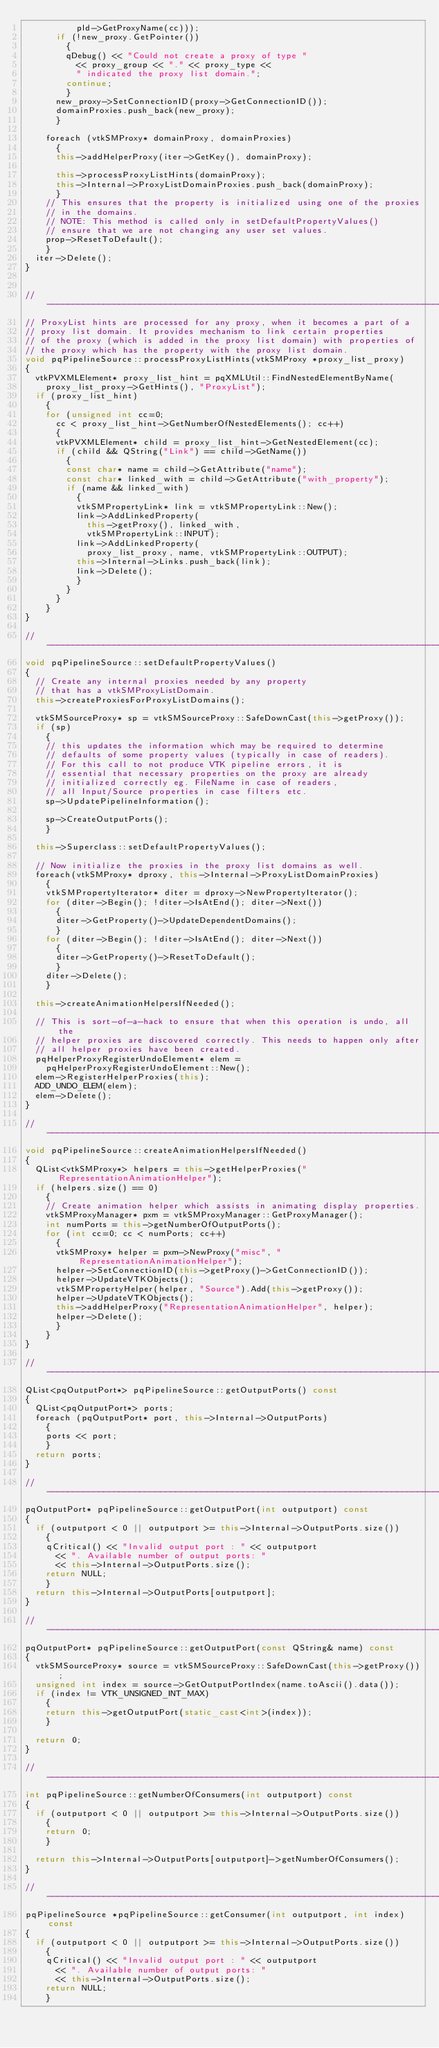<code> <loc_0><loc_0><loc_500><loc_500><_C++_>          pld->GetProxyName(cc)));
      if (!new_proxy.GetPointer())
        {
        qDebug() << "Could not create a proxy of type " 
          << proxy_group << "." << proxy_type <<
          " indicated the proxy list domain.";
        continue;
        }
      new_proxy->SetConnectionID(proxy->GetConnectionID());
      domainProxies.push_back(new_proxy);
      }

    foreach (vtkSMProxy* domainProxy, domainProxies)
      {
      this->addHelperProxy(iter->GetKey(), domainProxy);

      this->processProxyListHints(domainProxy);
      this->Internal->ProxyListDomainProxies.push_back(domainProxy);
      }
    // This ensures that the property is initialized using one of the proxies
    // in the domains.
    // NOTE: This method is called only in setDefaultPropertyValues()
    // ensure that we are not changing any user set values.
    prop->ResetToDefault();
    }
  iter->Delete();
}


//-----------------------------------------------------------------------------
// ProxyList hints are processed for any proxy, when it becomes a part of a 
// proxy list domain. It provides mechanism to link certain properties
// of the proxy (which is added in the proxy list domain) with properties of 
// the proxy which has the property with the proxy list domain.
void pqPipelineSource::processProxyListHints(vtkSMProxy *proxy_list_proxy)
{
  vtkPVXMLElement* proxy_list_hint = pqXMLUtil::FindNestedElementByName(
    proxy_list_proxy->GetHints(), "ProxyList");
  if (proxy_list_hint)
    {
    for (unsigned int cc=0; 
      cc < proxy_list_hint->GetNumberOfNestedElements(); cc++)
      {
      vtkPVXMLElement* child = proxy_list_hint->GetNestedElement(cc);
      if (child && QString("Link") == child->GetName())
        {
        const char* name = child->GetAttribute("name");
        const char* linked_with = child->GetAttribute("with_property");
        if (name && linked_with)
          {
          vtkSMPropertyLink* link = vtkSMPropertyLink::New();
          link->AddLinkedProperty(
            this->getProxy(), linked_with,
            vtkSMPropertyLink::INPUT);
          link->AddLinkedProperty(
            proxy_list_proxy, name, vtkSMPropertyLink::OUTPUT);
          this->Internal->Links.push_back(link);
          link->Delete();
          }
        }
      }
    }
}

//-----------------------------------------------------------------------------
void pqPipelineSource::setDefaultPropertyValues()
{
  // Create any internal proxies needed by any property
  // that has a vtkSMProxyListDomain.
  this->createProxiesForProxyListDomains();

  vtkSMSourceProxy* sp = vtkSMSourceProxy::SafeDownCast(this->getProxy());
  if (sp)
    {
    // this updates the information which may be required to determine
    // defaults of some property values (typically in case of readers).
    // For this call to not produce VTK pipeline errors, it is 
    // essential that necessary properties on the proxy are already
    // initialized correctly eg. FileName in case of readers,
    // all Input/Source properties in case filters etc.
    sp->UpdatePipelineInformation();

    sp->CreateOutputPorts();
    }

  this->Superclass::setDefaultPropertyValues();

  // Now initialize the proxies in the proxy list domains as well. 
  foreach(vtkSMProxy* dproxy, this->Internal->ProxyListDomainProxies)
    {
    vtkSMPropertyIterator* diter = dproxy->NewPropertyIterator();
    for (diter->Begin(); !diter->IsAtEnd(); diter->Next())
      {
      diter->GetProperty()->UpdateDependentDomains();
      }
    for (diter->Begin(); !diter->IsAtEnd(); diter->Next())
      {
      diter->GetProperty()->ResetToDefault();
      }
    diter->Delete();
    }

  this->createAnimationHelpersIfNeeded();

  // This is sort-of-a-hack to ensure that when this operation is undo, all the
  // helper proxies are discovered correctly. This needs to happen only after
  // all helper proxies have been created.
  pqHelperProxyRegisterUndoElement* elem = 
    pqHelperProxyRegisterUndoElement::New();
  elem->RegisterHelperProxies(this);
  ADD_UNDO_ELEM(elem);
  elem->Delete();
}

//-----------------------------------------------------------------------------
void pqPipelineSource::createAnimationHelpersIfNeeded()
{
  QList<vtkSMProxy*> helpers = this->getHelperProxies("RepresentationAnimationHelper");
  if (helpers.size() == 0)
    {
    // Create animation helper which assists in animating display properties.
    vtkSMProxyManager* pxm = vtkSMProxyManager::GetProxyManager();
    int numPorts = this->getNumberOfOutputPorts();
    for (int cc=0; cc < numPorts; cc++)
      {
      vtkSMProxy* helper = pxm->NewProxy("misc", "RepresentationAnimationHelper");
      helper->SetConnectionID(this->getProxy()->GetConnectionID());
      helper->UpdateVTKObjects();
      vtkSMPropertyHelper(helper, "Source").Add(this->getProxy());
      helper->UpdateVTKObjects();
      this->addHelperProxy("RepresentationAnimationHelper", helper);
      helper->Delete();
      }
    }
}

//-----------------------------------------------------------------------------
QList<pqOutputPort*> pqPipelineSource::getOutputPorts() const
{
  QList<pqOutputPort*> ports;
  foreach (pqOutputPort* port, this->Internal->OutputPorts)
    {
    ports << port;
    }
  return ports;
}

//-----------------------------------------------------------------------------
pqOutputPort* pqPipelineSource::getOutputPort(int outputport) const
{
  if (outputport < 0 || outputport >= this->Internal->OutputPorts.size())
    {
    qCritical() << "Invalid output port : " << outputport
      << ". Available number of output ports: " 
      << this->Internal->OutputPorts.size();
    return NULL;
    }
  return this->Internal->OutputPorts[outputport];
}

//-----------------------------------------------------------------------------
pqOutputPort* pqPipelineSource::getOutputPort(const QString& name) const
{
  vtkSMSourceProxy* source = vtkSMSourceProxy::SafeDownCast(this->getProxy());
  unsigned int index = source->GetOutputPortIndex(name.toAscii().data());
  if (index != VTK_UNSIGNED_INT_MAX)
    {
    return this->getOutputPort(static_cast<int>(index));
    }

  return 0;
}

//-----------------------------------------------------------------------------
int pqPipelineSource::getNumberOfConsumers(int outputport) const
{
  if (outputport < 0 || outputport >= this->Internal->OutputPorts.size())
    {
    return 0;
    }

  return this->Internal->OutputPorts[outputport]->getNumberOfConsumers();
}

//-----------------------------------------------------------------------------
pqPipelineSource *pqPipelineSource::getConsumer(int outputport, int index) const
{
  if (outputport < 0 || outputport >= this->Internal->OutputPorts.size())
    {
    qCritical() << "Invalid output port : " << outputport
      << ". Available number of output ports: " 
      << this->Internal->OutputPorts.size();
    return NULL;
    }
</code> 